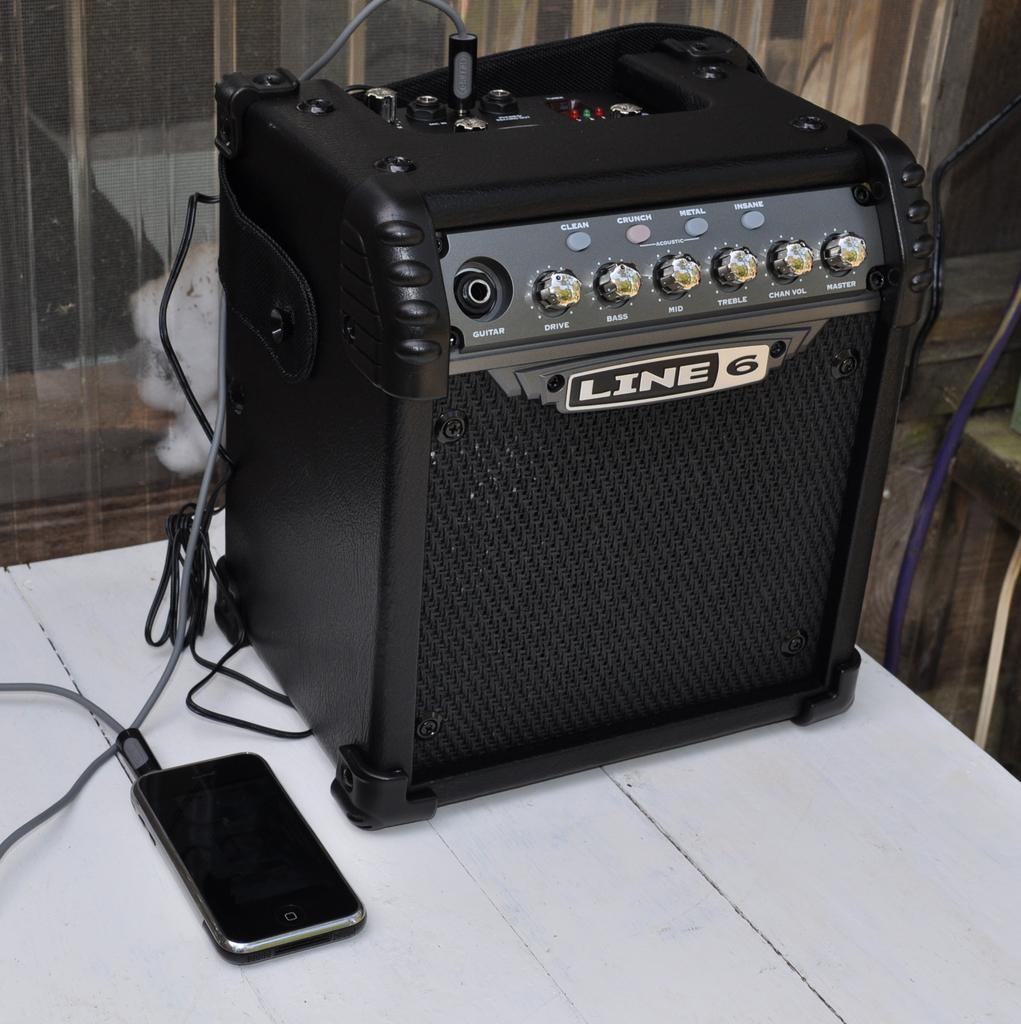<image>
Relay a brief, clear account of the picture shown. A tiny amplifier that is by the brand Line 6. 